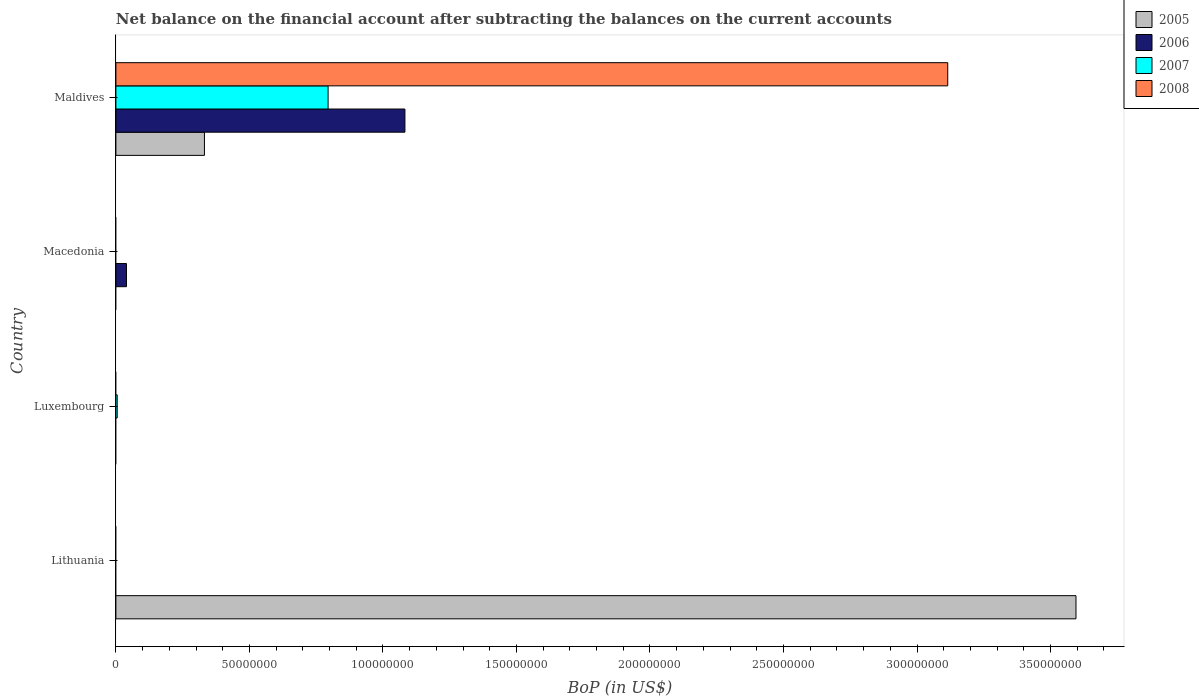How many different coloured bars are there?
Ensure brevity in your answer.  4. How many bars are there on the 1st tick from the top?
Offer a very short reply. 4. What is the label of the 1st group of bars from the top?
Offer a terse response. Maldives. In how many cases, is the number of bars for a given country not equal to the number of legend labels?
Your answer should be very brief. 3. Across all countries, what is the maximum Balance of Payments in 2007?
Provide a succinct answer. 7.95e+07. Across all countries, what is the minimum Balance of Payments in 2008?
Keep it short and to the point. 0. In which country was the Balance of Payments in 2008 maximum?
Provide a short and direct response. Maldives. What is the total Balance of Payments in 2006 in the graph?
Make the answer very short. 1.12e+08. What is the difference between the Balance of Payments in 2006 in Maldives and the Balance of Payments in 2008 in Luxembourg?
Ensure brevity in your answer.  1.08e+08. What is the average Balance of Payments in 2005 per country?
Your response must be concise. 9.82e+07. What is the difference between the Balance of Payments in 2006 and Balance of Payments in 2008 in Maldives?
Provide a succinct answer. -2.03e+08. What is the ratio of the Balance of Payments in 2007 in Luxembourg to that in Maldives?
Make the answer very short. 0.01. What is the difference between the highest and the lowest Balance of Payments in 2008?
Offer a very short reply. 3.11e+08. In how many countries, is the Balance of Payments in 2007 greater than the average Balance of Payments in 2007 taken over all countries?
Keep it short and to the point. 1. Is it the case that in every country, the sum of the Balance of Payments in 2006 and Balance of Payments in 2008 is greater than the Balance of Payments in 2005?
Give a very brief answer. No. Are the values on the major ticks of X-axis written in scientific E-notation?
Make the answer very short. No. Does the graph contain any zero values?
Offer a terse response. Yes. Does the graph contain grids?
Keep it short and to the point. No. How many legend labels are there?
Your answer should be compact. 4. What is the title of the graph?
Ensure brevity in your answer.  Net balance on the financial account after subtracting the balances on the current accounts. Does "1988" appear as one of the legend labels in the graph?
Provide a succinct answer. No. What is the label or title of the X-axis?
Make the answer very short. BoP (in US$). What is the label or title of the Y-axis?
Offer a terse response. Country. What is the BoP (in US$) of 2005 in Lithuania?
Provide a short and direct response. 3.60e+08. What is the BoP (in US$) of 2006 in Lithuania?
Offer a very short reply. 0. What is the BoP (in US$) in 2007 in Luxembourg?
Provide a short and direct response. 4.90e+05. What is the BoP (in US$) in 2006 in Macedonia?
Your response must be concise. 3.96e+06. What is the BoP (in US$) in 2007 in Macedonia?
Your answer should be compact. 0. What is the BoP (in US$) in 2008 in Macedonia?
Keep it short and to the point. 0. What is the BoP (in US$) of 2005 in Maldives?
Keep it short and to the point. 3.32e+07. What is the BoP (in US$) of 2006 in Maldives?
Your response must be concise. 1.08e+08. What is the BoP (in US$) of 2007 in Maldives?
Keep it short and to the point. 7.95e+07. What is the BoP (in US$) of 2008 in Maldives?
Your response must be concise. 3.11e+08. Across all countries, what is the maximum BoP (in US$) of 2005?
Provide a short and direct response. 3.60e+08. Across all countries, what is the maximum BoP (in US$) in 2006?
Provide a succinct answer. 1.08e+08. Across all countries, what is the maximum BoP (in US$) in 2007?
Ensure brevity in your answer.  7.95e+07. Across all countries, what is the maximum BoP (in US$) of 2008?
Keep it short and to the point. 3.11e+08. Across all countries, what is the minimum BoP (in US$) in 2005?
Offer a very short reply. 0. What is the total BoP (in US$) in 2005 in the graph?
Give a very brief answer. 3.93e+08. What is the total BoP (in US$) of 2006 in the graph?
Make the answer very short. 1.12e+08. What is the total BoP (in US$) in 2007 in the graph?
Ensure brevity in your answer.  8.00e+07. What is the total BoP (in US$) of 2008 in the graph?
Ensure brevity in your answer.  3.11e+08. What is the difference between the BoP (in US$) of 2005 in Lithuania and that in Maldives?
Offer a very short reply. 3.26e+08. What is the difference between the BoP (in US$) in 2007 in Luxembourg and that in Maldives?
Your answer should be compact. -7.90e+07. What is the difference between the BoP (in US$) of 2006 in Macedonia and that in Maldives?
Give a very brief answer. -1.04e+08. What is the difference between the BoP (in US$) in 2005 in Lithuania and the BoP (in US$) in 2007 in Luxembourg?
Your answer should be very brief. 3.59e+08. What is the difference between the BoP (in US$) in 2005 in Lithuania and the BoP (in US$) in 2006 in Macedonia?
Give a very brief answer. 3.56e+08. What is the difference between the BoP (in US$) of 2005 in Lithuania and the BoP (in US$) of 2006 in Maldives?
Provide a succinct answer. 2.51e+08. What is the difference between the BoP (in US$) of 2005 in Lithuania and the BoP (in US$) of 2007 in Maldives?
Keep it short and to the point. 2.80e+08. What is the difference between the BoP (in US$) of 2005 in Lithuania and the BoP (in US$) of 2008 in Maldives?
Keep it short and to the point. 4.80e+07. What is the difference between the BoP (in US$) of 2007 in Luxembourg and the BoP (in US$) of 2008 in Maldives?
Ensure brevity in your answer.  -3.11e+08. What is the difference between the BoP (in US$) of 2006 in Macedonia and the BoP (in US$) of 2007 in Maldives?
Keep it short and to the point. -7.55e+07. What is the difference between the BoP (in US$) in 2006 in Macedonia and the BoP (in US$) in 2008 in Maldives?
Provide a succinct answer. -3.08e+08. What is the average BoP (in US$) in 2005 per country?
Make the answer very short. 9.82e+07. What is the average BoP (in US$) of 2006 per country?
Provide a succinct answer. 2.80e+07. What is the average BoP (in US$) of 2007 per country?
Your response must be concise. 2.00e+07. What is the average BoP (in US$) in 2008 per country?
Keep it short and to the point. 7.79e+07. What is the difference between the BoP (in US$) of 2005 and BoP (in US$) of 2006 in Maldives?
Offer a terse response. -7.51e+07. What is the difference between the BoP (in US$) of 2005 and BoP (in US$) of 2007 in Maldives?
Offer a terse response. -4.63e+07. What is the difference between the BoP (in US$) in 2005 and BoP (in US$) in 2008 in Maldives?
Offer a terse response. -2.78e+08. What is the difference between the BoP (in US$) in 2006 and BoP (in US$) in 2007 in Maldives?
Your response must be concise. 2.88e+07. What is the difference between the BoP (in US$) of 2006 and BoP (in US$) of 2008 in Maldives?
Give a very brief answer. -2.03e+08. What is the difference between the BoP (in US$) in 2007 and BoP (in US$) in 2008 in Maldives?
Your response must be concise. -2.32e+08. What is the ratio of the BoP (in US$) in 2005 in Lithuania to that in Maldives?
Provide a succinct answer. 10.84. What is the ratio of the BoP (in US$) in 2007 in Luxembourg to that in Maldives?
Provide a short and direct response. 0.01. What is the ratio of the BoP (in US$) in 2006 in Macedonia to that in Maldives?
Your response must be concise. 0.04. What is the difference between the highest and the lowest BoP (in US$) in 2005?
Your answer should be compact. 3.60e+08. What is the difference between the highest and the lowest BoP (in US$) of 2006?
Ensure brevity in your answer.  1.08e+08. What is the difference between the highest and the lowest BoP (in US$) of 2007?
Provide a succinct answer. 7.95e+07. What is the difference between the highest and the lowest BoP (in US$) of 2008?
Provide a succinct answer. 3.11e+08. 